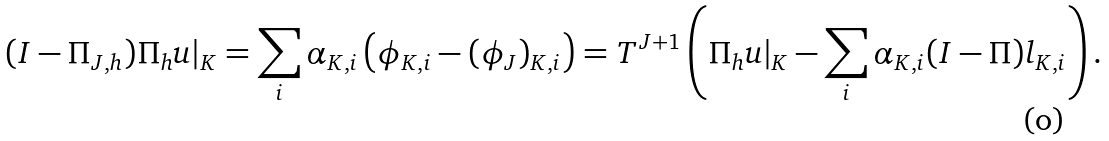<formula> <loc_0><loc_0><loc_500><loc_500>( I - \Pi _ { J , h } ) \Pi _ { h } u | _ { K } = \sum _ { i } \alpha _ { K , i } \left ( \phi _ { K , i } - ( \phi _ { J } ) _ { K , i } \right ) = T ^ { J + 1 } \left ( \Pi _ { h } u | _ { K } - \sum _ { i } \alpha _ { K , i } ( I - \Pi ) l _ { K , i } \right ) .</formula> 